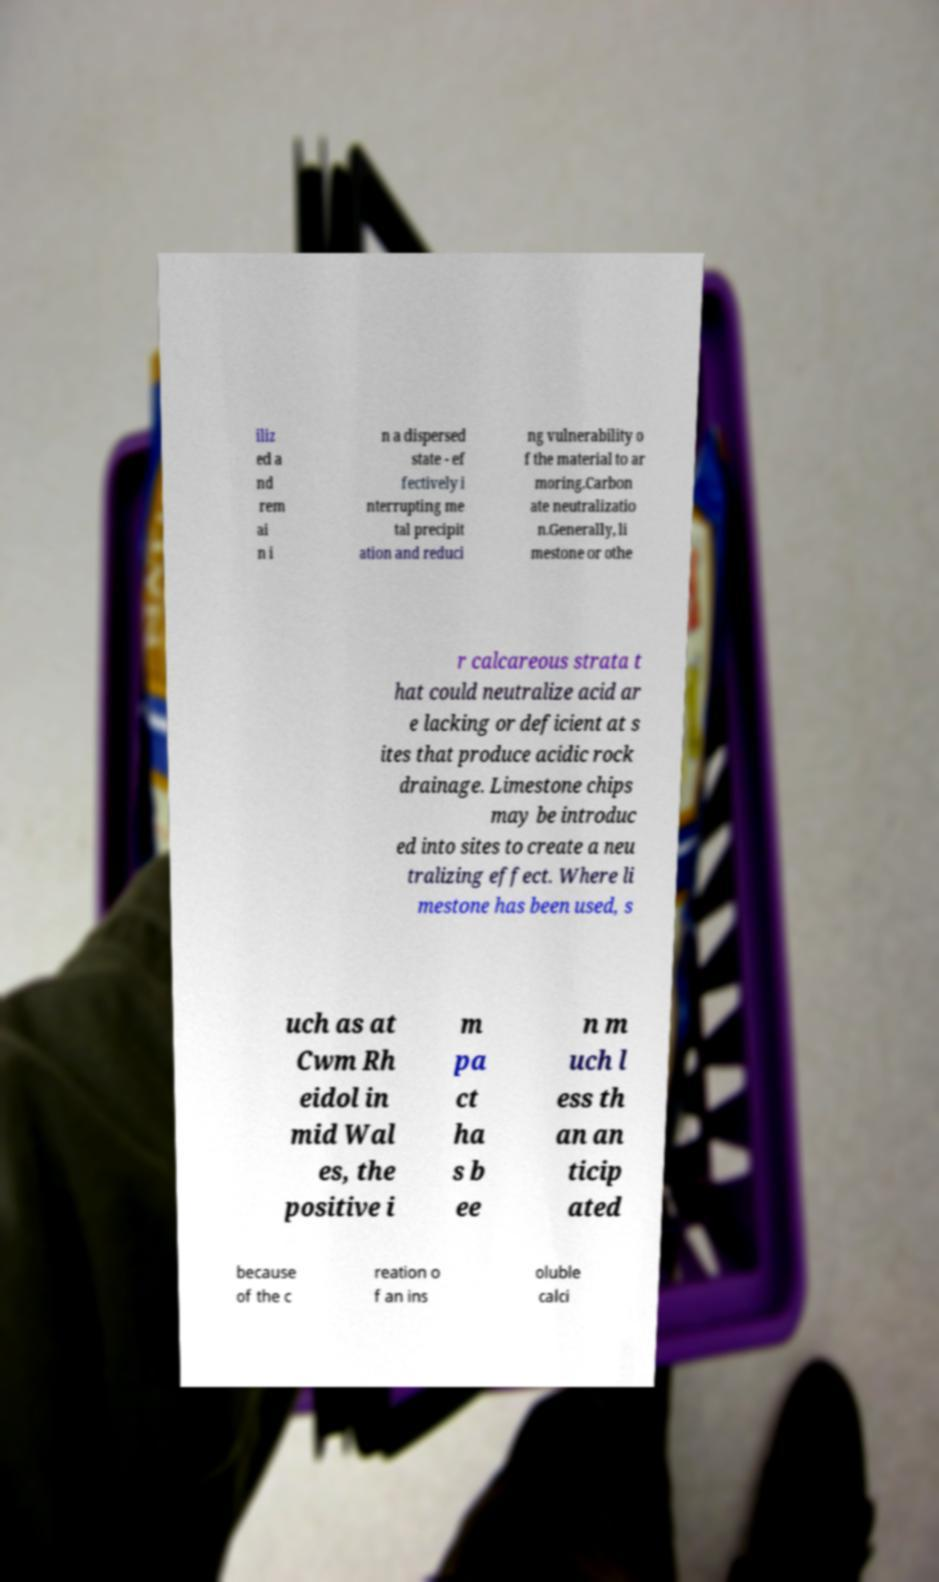Could you assist in decoding the text presented in this image and type it out clearly? iliz ed a nd rem ai n i n a dispersed state - ef fectively i nterrupting me tal precipit ation and reduci ng vulnerability o f the material to ar moring.Carbon ate neutralizatio n.Generally, li mestone or othe r calcareous strata t hat could neutralize acid ar e lacking or deficient at s ites that produce acidic rock drainage. Limestone chips may be introduc ed into sites to create a neu tralizing effect. Where li mestone has been used, s uch as at Cwm Rh eidol in mid Wal es, the positive i m pa ct ha s b ee n m uch l ess th an an ticip ated because of the c reation o f an ins oluble calci 